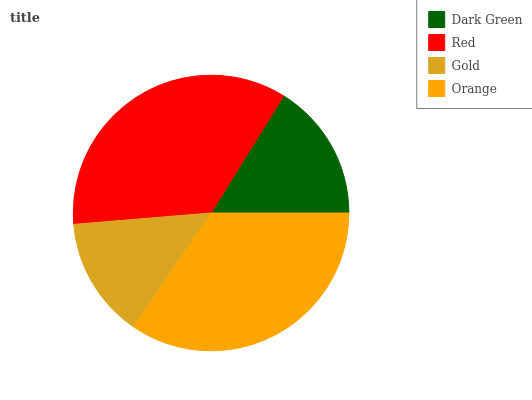Is Gold the minimum?
Answer yes or no. Yes. Is Red the maximum?
Answer yes or no. Yes. Is Red the minimum?
Answer yes or no. No. Is Gold the maximum?
Answer yes or no. No. Is Red greater than Gold?
Answer yes or no. Yes. Is Gold less than Red?
Answer yes or no. Yes. Is Gold greater than Red?
Answer yes or no. No. Is Red less than Gold?
Answer yes or no. No. Is Orange the high median?
Answer yes or no. Yes. Is Dark Green the low median?
Answer yes or no. Yes. Is Red the high median?
Answer yes or no. No. Is Orange the low median?
Answer yes or no. No. 